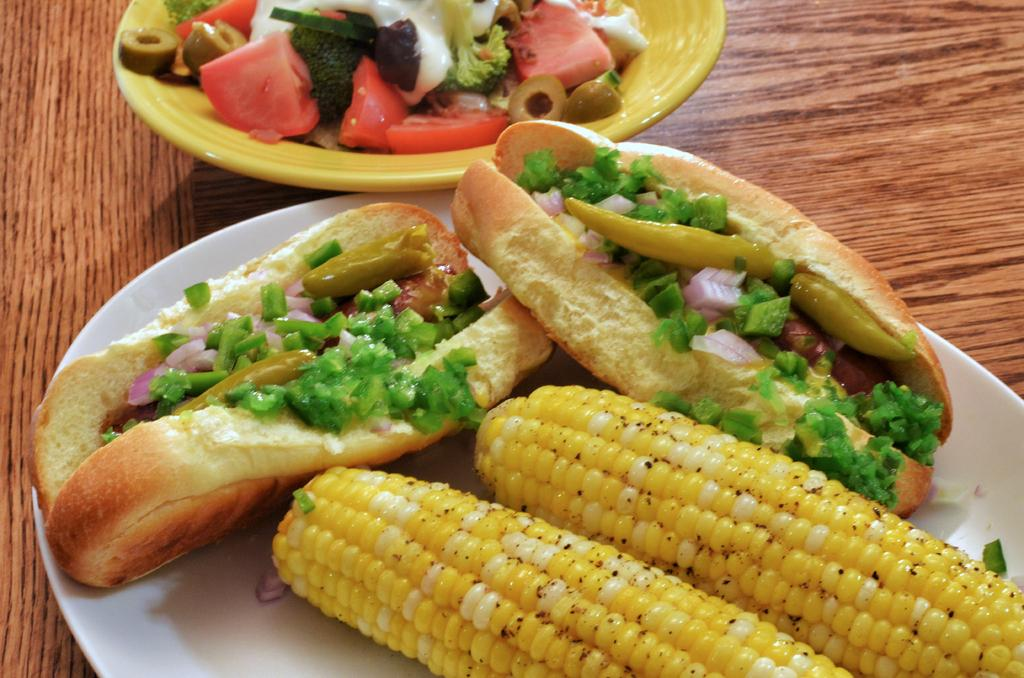How many plates are visible in the image? There are two plates in the image. Where are the plates located? The plates are on a surface. What type of food can be seen on the plates? There is a variety of food on the plates. What type of tax is being discussed on the plates in the image? There is no discussion of tax on the plates in the image; they contain food. 